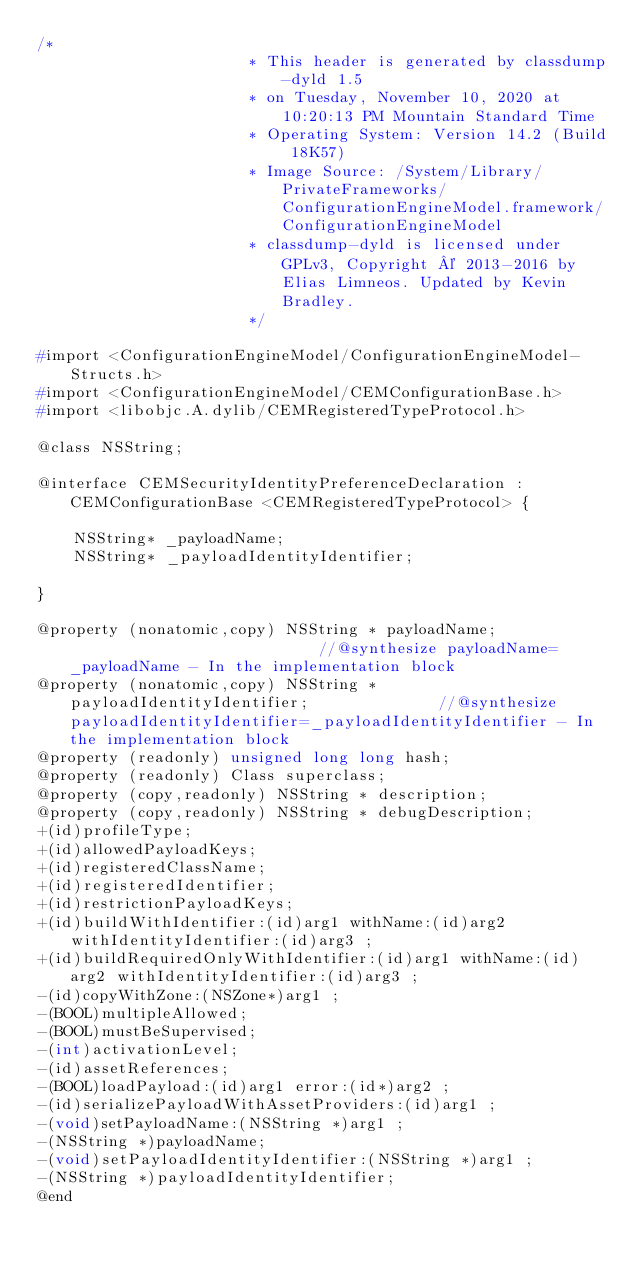<code> <loc_0><loc_0><loc_500><loc_500><_C_>/*
                       * This header is generated by classdump-dyld 1.5
                       * on Tuesday, November 10, 2020 at 10:20:13 PM Mountain Standard Time
                       * Operating System: Version 14.2 (Build 18K57)
                       * Image Source: /System/Library/PrivateFrameworks/ConfigurationEngineModel.framework/ConfigurationEngineModel
                       * classdump-dyld is licensed under GPLv3, Copyright © 2013-2016 by Elias Limneos. Updated by Kevin Bradley.
                       */

#import <ConfigurationEngineModel/ConfigurationEngineModel-Structs.h>
#import <ConfigurationEngineModel/CEMConfigurationBase.h>
#import <libobjc.A.dylib/CEMRegisteredTypeProtocol.h>

@class NSString;

@interface CEMSecurityIdentityPreferenceDeclaration : CEMConfigurationBase <CEMRegisteredTypeProtocol> {

	NSString* _payloadName;
	NSString* _payloadIdentityIdentifier;

}

@property (nonatomic,copy) NSString * payloadName;                            //@synthesize payloadName=_payloadName - In the implementation block
@property (nonatomic,copy) NSString * payloadIdentityIdentifier;              //@synthesize payloadIdentityIdentifier=_payloadIdentityIdentifier - In the implementation block
@property (readonly) unsigned long long hash; 
@property (readonly) Class superclass; 
@property (copy,readonly) NSString * description; 
@property (copy,readonly) NSString * debugDescription; 
+(id)profileType;
+(id)allowedPayloadKeys;
+(id)registeredClassName;
+(id)registeredIdentifier;
+(id)restrictionPayloadKeys;
+(id)buildWithIdentifier:(id)arg1 withName:(id)arg2 withIdentityIdentifier:(id)arg3 ;
+(id)buildRequiredOnlyWithIdentifier:(id)arg1 withName:(id)arg2 withIdentityIdentifier:(id)arg3 ;
-(id)copyWithZone:(NSZone*)arg1 ;
-(BOOL)multipleAllowed;
-(BOOL)mustBeSupervised;
-(int)activationLevel;
-(id)assetReferences;
-(BOOL)loadPayload:(id)arg1 error:(id*)arg2 ;
-(id)serializePayloadWithAssetProviders:(id)arg1 ;
-(void)setPayloadName:(NSString *)arg1 ;
-(NSString *)payloadName;
-(void)setPayloadIdentityIdentifier:(NSString *)arg1 ;
-(NSString *)payloadIdentityIdentifier;
@end

</code> 